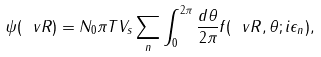<formula> <loc_0><loc_0><loc_500><loc_500>\psi ( \ v R ) = N _ { 0 } \pi T V _ { s } \sum _ { n } \int _ { 0 } ^ { 2 \pi } \frac { d \theta } { 2 \pi } f ( \ v R , \theta ; i \epsilon _ { n } ) ,</formula> 